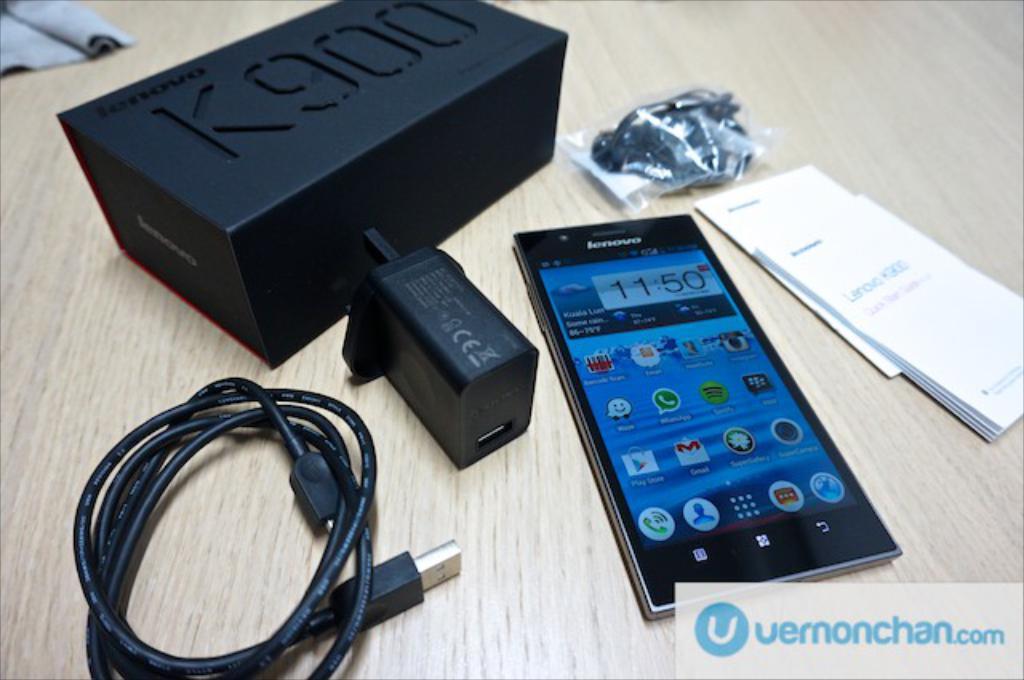What kind of phone is that?
Provide a short and direct response. Lenovo. 